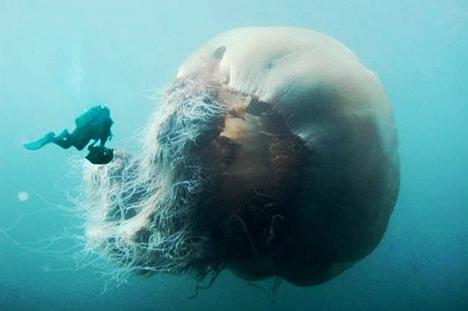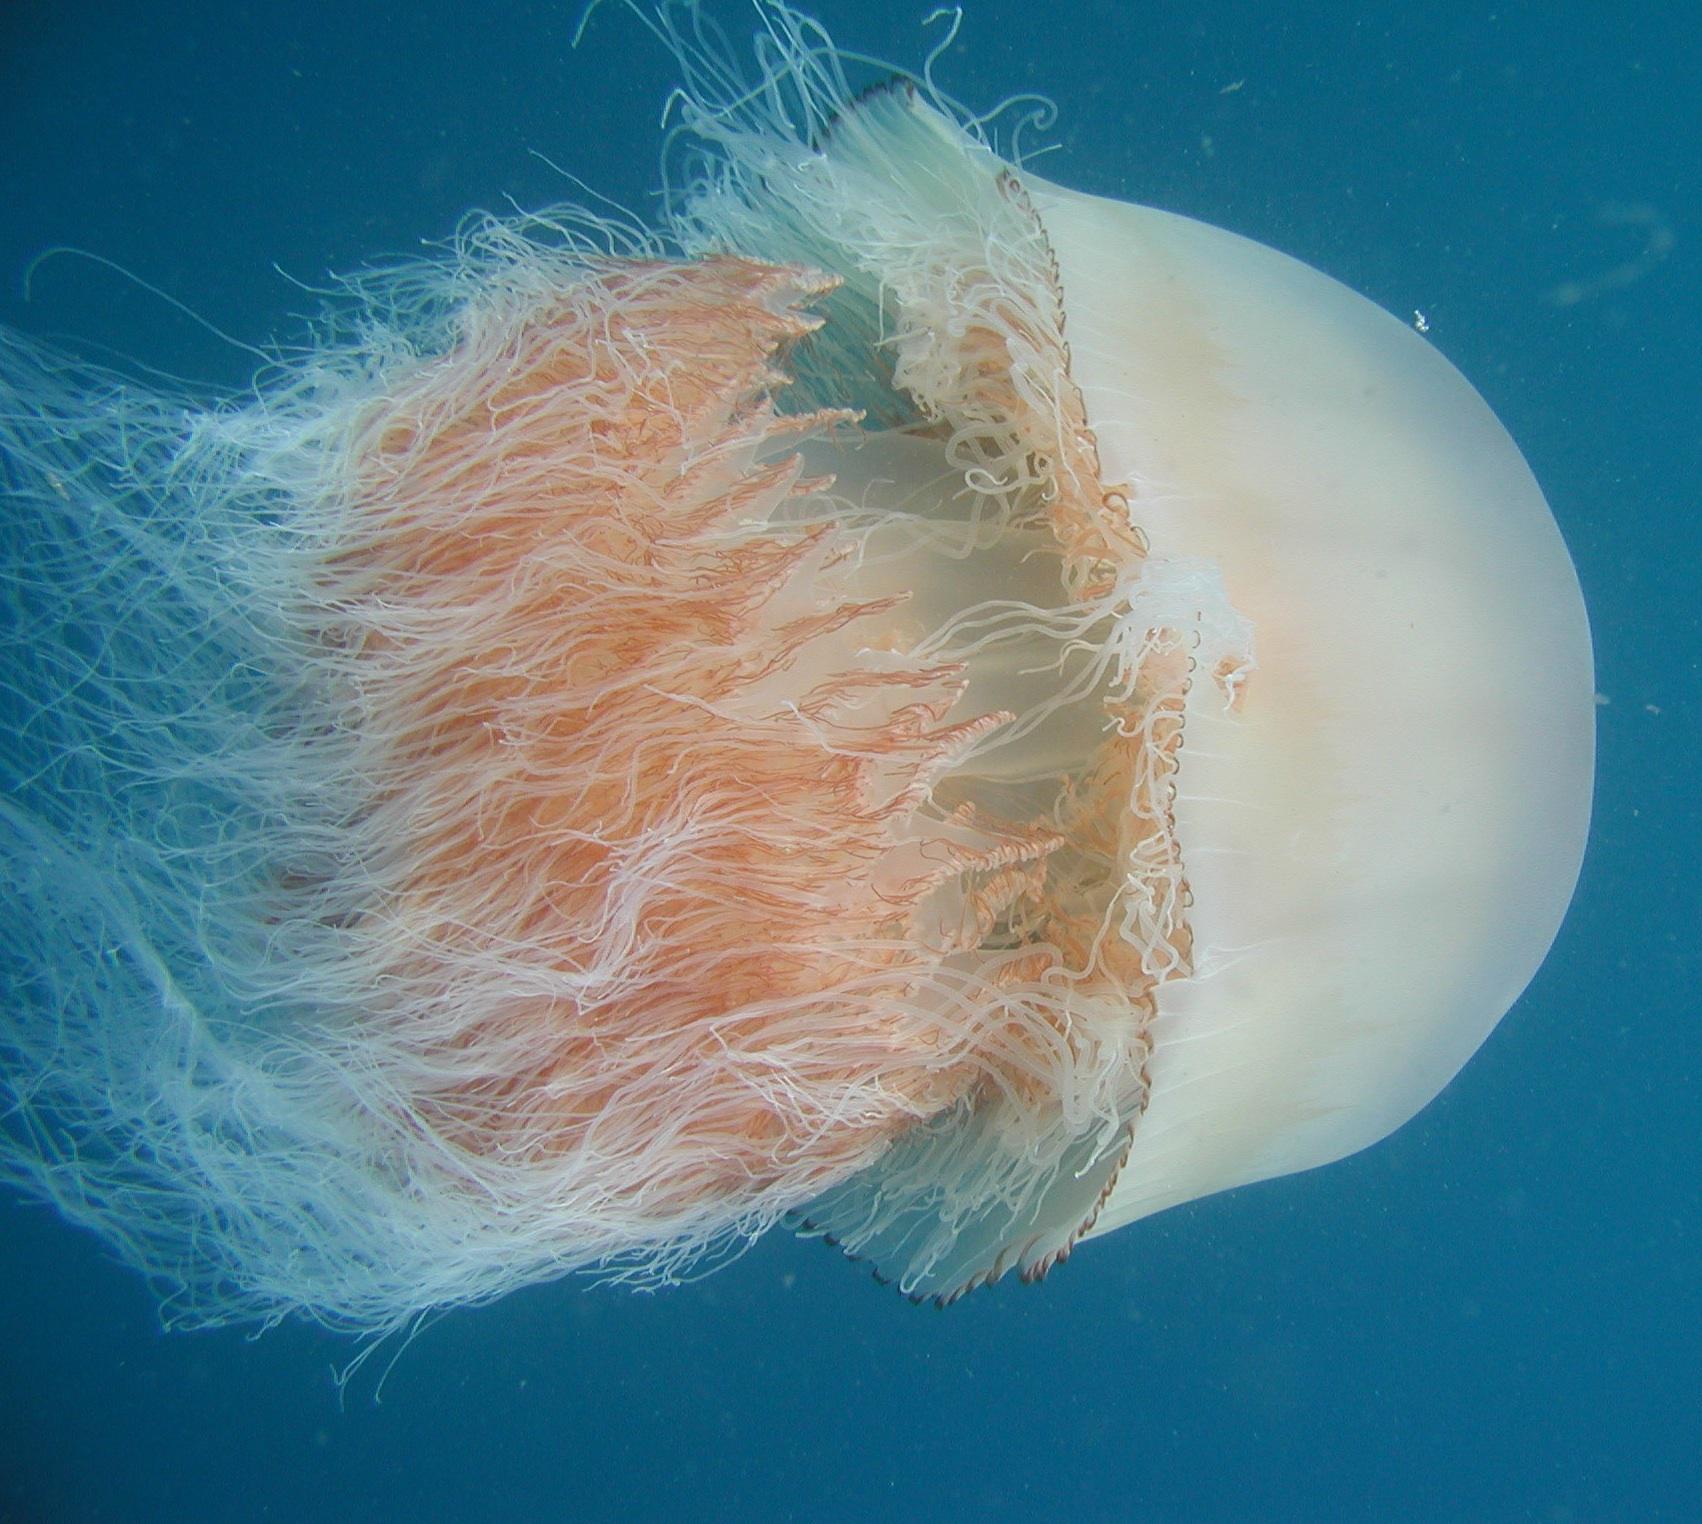The first image is the image on the left, the second image is the image on the right. Given the left and right images, does the statement "One image shows exactly one peachy colored jellyfish, and no scuba diver present." hold true? Answer yes or no. Yes. The first image is the image on the left, the second image is the image on the right. For the images shown, is this caption "There are two jellyfish, each one traveling the opposite direction as the other." true? Answer yes or no. No. 